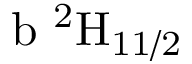<formula> <loc_0><loc_0><loc_500><loc_500>b \ ^ { 2 } H _ { 1 1 / 2 }</formula> 